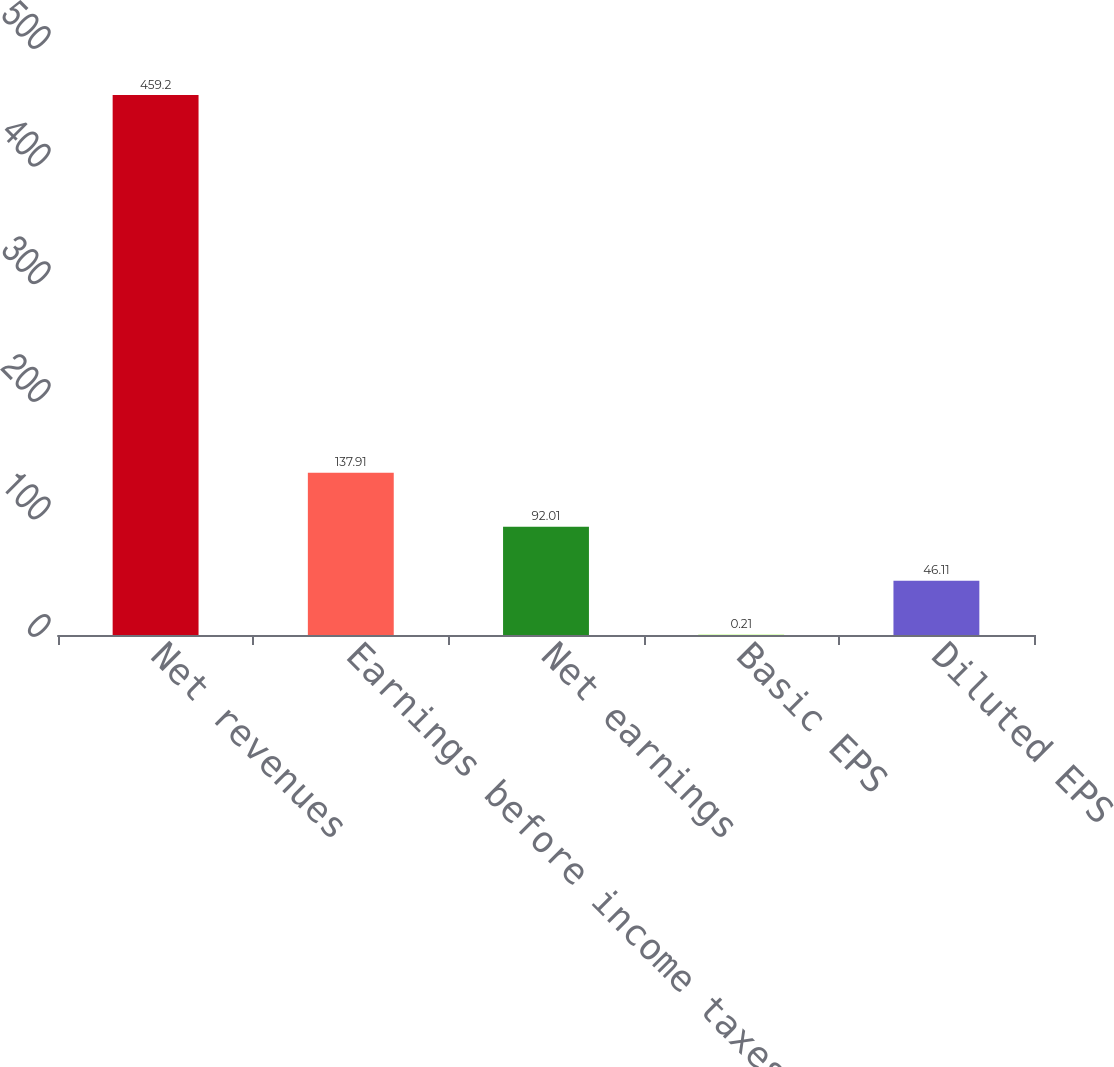Convert chart to OTSL. <chart><loc_0><loc_0><loc_500><loc_500><bar_chart><fcel>Net revenues<fcel>Earnings before income taxes<fcel>Net earnings<fcel>Basic EPS<fcel>Diluted EPS<nl><fcel>459.2<fcel>137.91<fcel>92.01<fcel>0.21<fcel>46.11<nl></chart> 